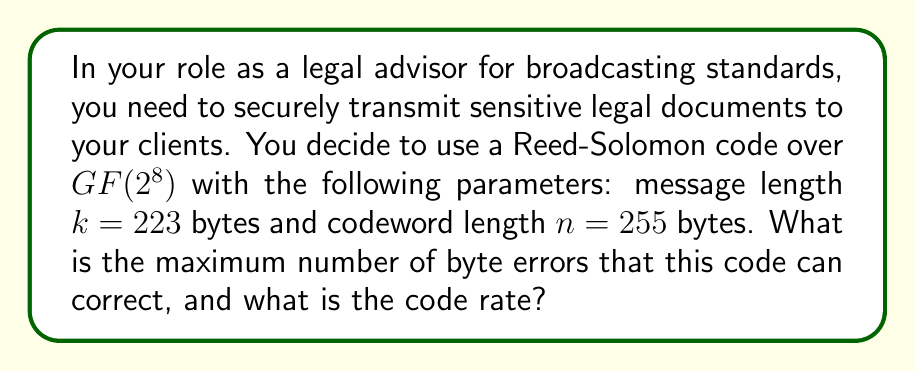Provide a solution to this math problem. To solve this problem, we need to understand the properties of Reed-Solomon codes and how they relate to error correction capabilities.

1. Error correction capability:
   Reed-Solomon codes can correct up to $t$ errors, where $t$ is given by:
   $$t = \left\lfloor\frac{n-k}{2}\right\rfloor$$

   In this case:
   $$t = \left\lfloor\frac{255-223}{2}\right\rfloor = \left\lfloor\frac{32}{2}\right\rfloor = 16$$

   Therefore, this code can correct up to 16 byte errors.

2. Code rate:
   The code rate $R$ is defined as the ratio of the message length $k$ to the codeword length $n$:
   $$R = \frac{k}{n}$$

   For this code:
   $$R = \frac{223}{255} \approx 0.8745$$

   This can be expressed as a percentage: $87.45\%$

The code rate represents the proportion of the transmitted data that contains actual information. A higher code rate means more efficient transmission but less error correction capability.
Answer: The Reed-Solomon code can correct up to 16 byte errors, and the code rate is $\frac{223}{255} \approx 0.8745$ or $87.45\%$. 